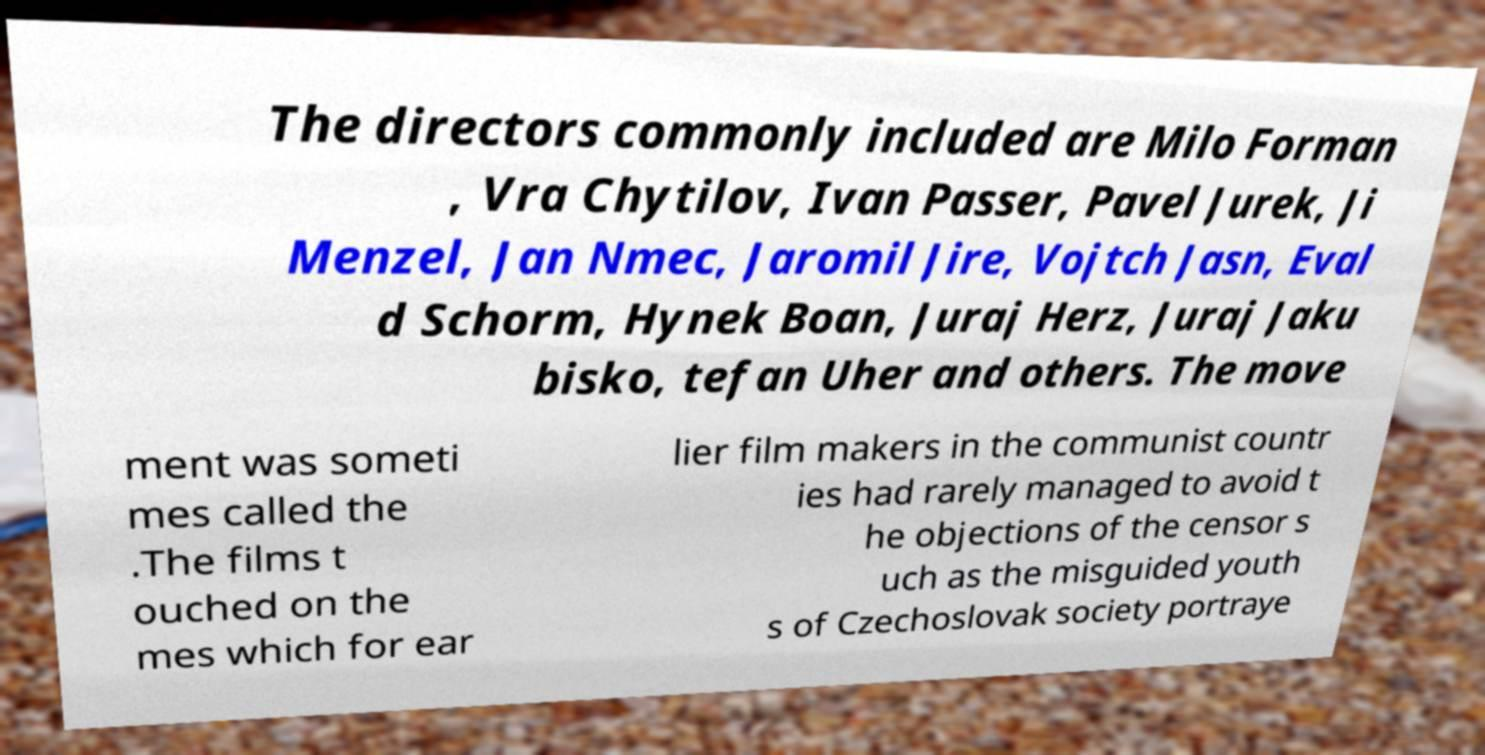Please identify and transcribe the text found in this image. The directors commonly included are Milo Forman , Vra Chytilov, Ivan Passer, Pavel Jurek, Ji Menzel, Jan Nmec, Jaromil Jire, Vojtch Jasn, Eval d Schorm, Hynek Boan, Juraj Herz, Juraj Jaku bisko, tefan Uher and others. The move ment was someti mes called the .The films t ouched on the mes which for ear lier film makers in the communist countr ies had rarely managed to avoid t he objections of the censor s uch as the misguided youth s of Czechoslovak society portraye 